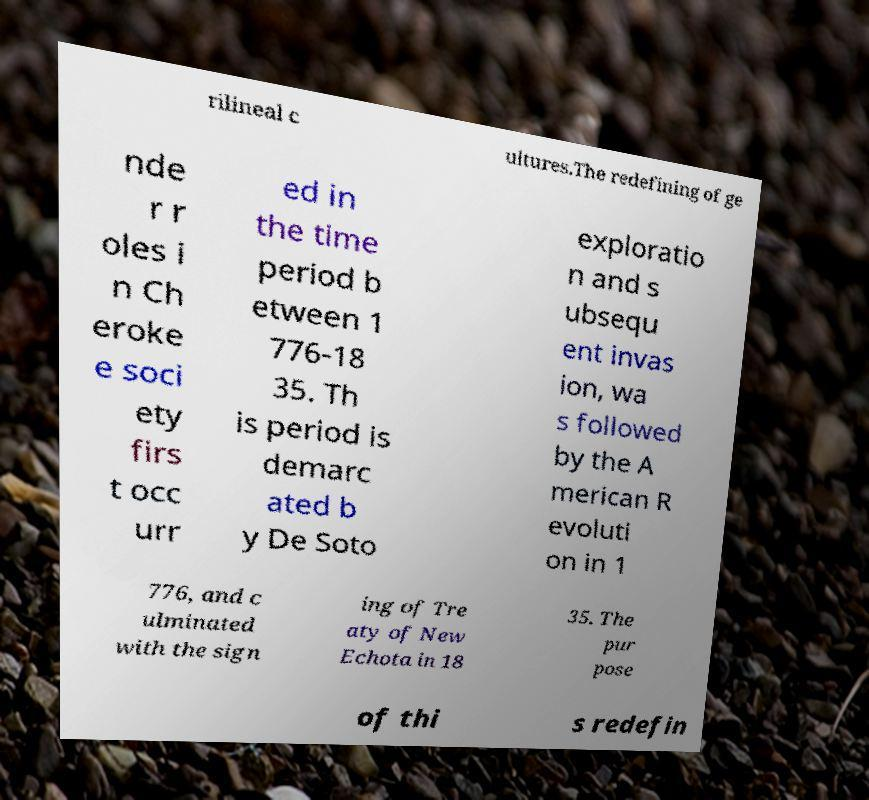I need the written content from this picture converted into text. Can you do that? rilineal c ultures.The redefining of ge nde r r oles i n Ch eroke e soci ety firs t occ urr ed in the time period b etween 1 776-18 35. Th is period is demarc ated b y De Soto exploratio n and s ubsequ ent invas ion, wa s followed by the A merican R evoluti on in 1 776, and c ulminated with the sign ing of Tre aty of New Echota in 18 35. The pur pose of thi s redefin 